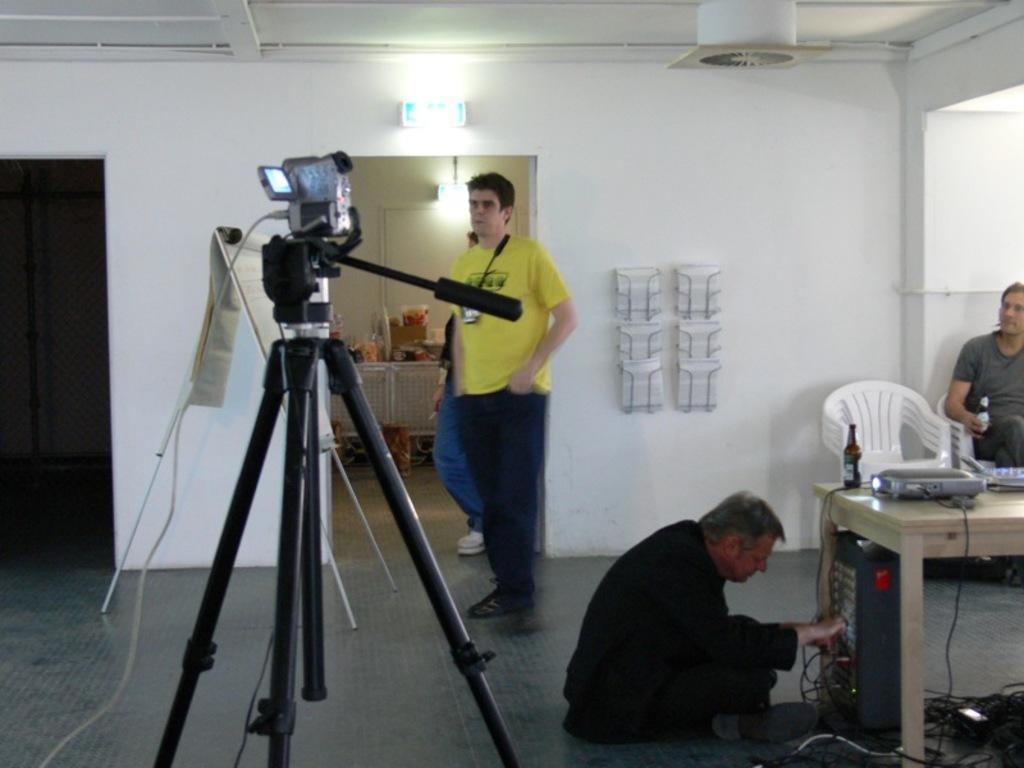Could you give a brief overview of what you see in this image? As we can see in the image there is a white color wall, few people here and there, chair, camera and a table. On table there is a projector and a bottle. 